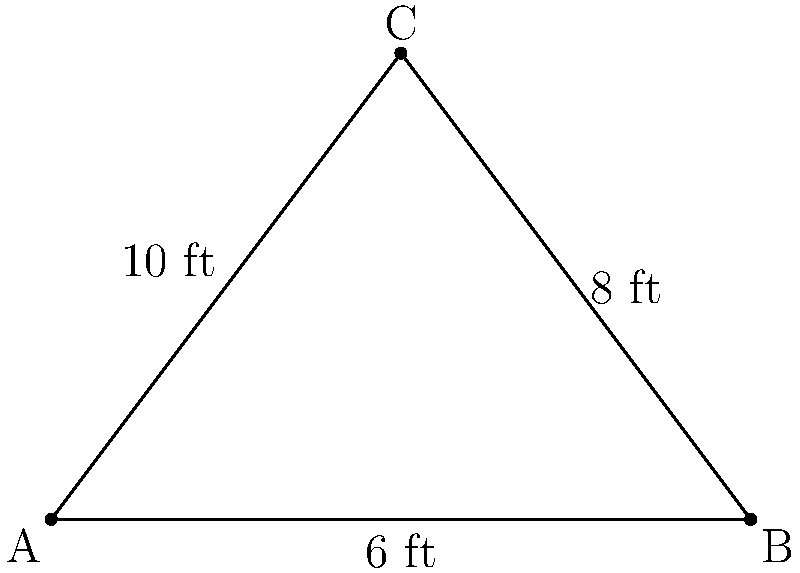A local shop owner wants to create a triangular "Sale" banner for their window display. The base of the triangle is 6 feet, and the height is 8 feet. What is the area of the banner in square feet? Let's approach this step-by-step using a formula that's easy to remember:

1. The formula for the area of a triangle is:
   Area = $\frac{1}{2}$ × base × height

2. We're given:
   - Base = 6 feet
   - Height = 8 feet

3. Let's plug these values into our formula:
   Area = $\frac{1}{2}$ × 6 × 8

4. Now, let's calculate:
   Area = $\frac{1}{2}$ × 48
   Area = 24

5. Therefore, the area of the triangular banner is 24 square feet.

Think of it this way: if this were a rectangle, it would be 6 feet by 8 feet, with an area of 48 square feet. The triangle is exactly half of that, so we divide by 2 to get 24 square feet.
Answer: 24 square feet 